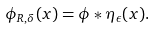<formula> <loc_0><loc_0><loc_500><loc_500>\phi _ { R , \delta } ( x ) = \phi * \eta _ { \epsilon } ( x ) .</formula> 